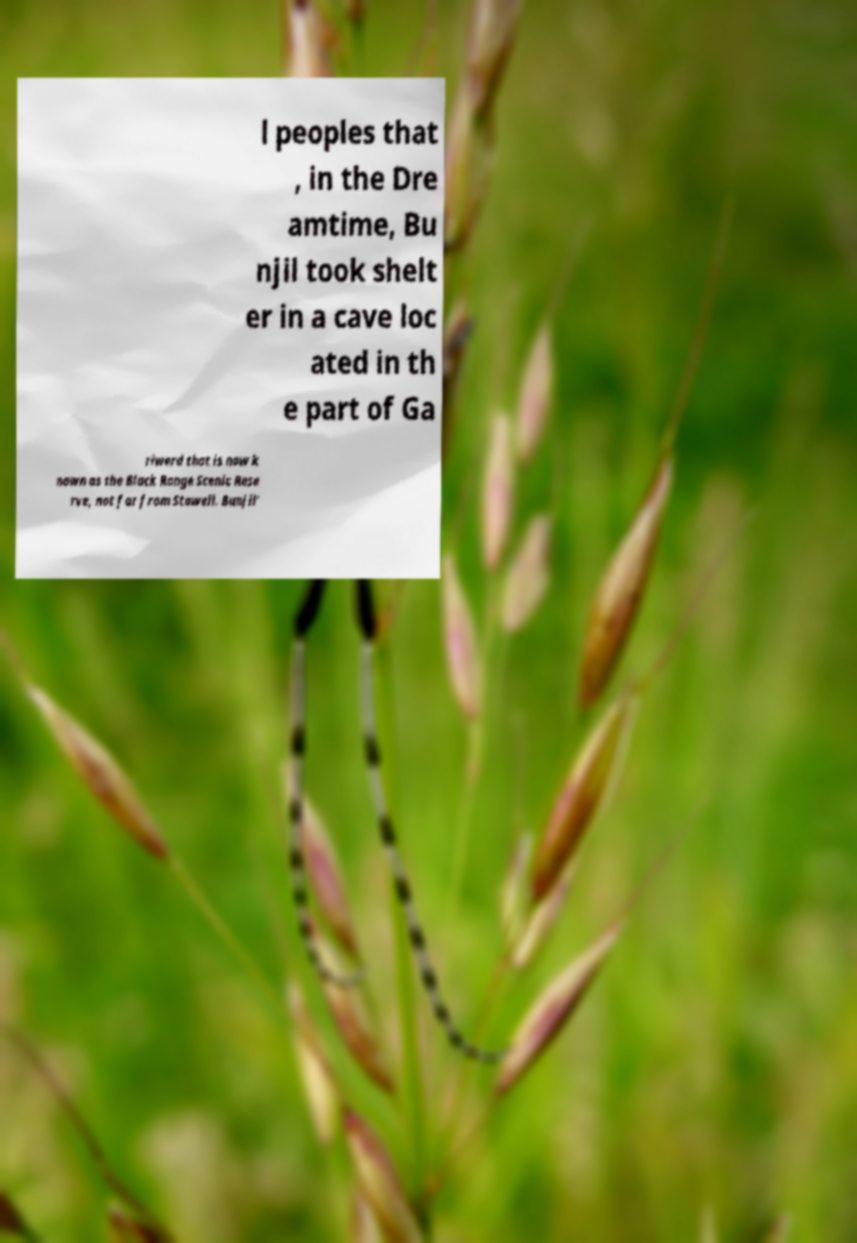Can you read and provide the text displayed in the image?This photo seems to have some interesting text. Can you extract and type it out for me? l peoples that , in the Dre amtime, Bu njil took shelt er in a cave loc ated in th e part of Ga riwerd that is now k nown as the Black Range Scenic Rese rve, not far from Stawell. Bunjil' 